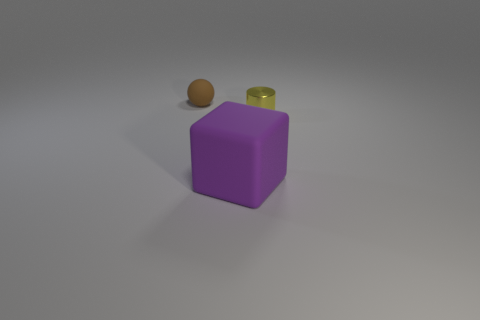Add 1 tiny metallic things. How many objects exist? 4 Subtract all cylinders. How many objects are left? 2 Add 1 brown rubber things. How many brown rubber things exist? 2 Subtract 0 gray cubes. How many objects are left? 3 Subtract all large purple blocks. Subtract all large matte balls. How many objects are left? 2 Add 2 big purple rubber cubes. How many big purple rubber cubes are left? 3 